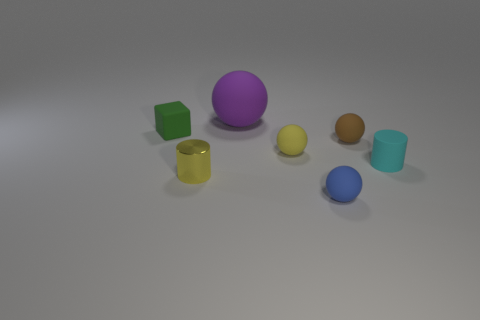Is there any other thing that is made of the same material as the tiny yellow cylinder?
Provide a short and direct response. No. There is a metal cylinder; does it have the same color as the sphere that is on the left side of the tiny yellow rubber object?
Ensure brevity in your answer.  No. How many other objects are the same color as the small metallic thing?
Give a very brief answer. 1. Is the size of the rubber sphere behind the rubber block the same as the cylinder to the left of the large object?
Offer a very short reply. No. The small ball that is in front of the small cyan rubber thing is what color?
Ensure brevity in your answer.  Blue. Is the number of cyan objects that are behind the tiny cyan cylinder less than the number of rubber cubes?
Your response must be concise. Yes. Do the purple ball and the small cyan cylinder have the same material?
Keep it short and to the point. Yes. What is the size of the cyan thing that is the same shape as the yellow metal thing?
Keep it short and to the point. Small. How many objects are small objects on the left side of the purple thing or balls that are in front of the metallic cylinder?
Make the answer very short. 3. Is the number of yellow rubber balls less than the number of small green metallic balls?
Offer a very short reply. No. 